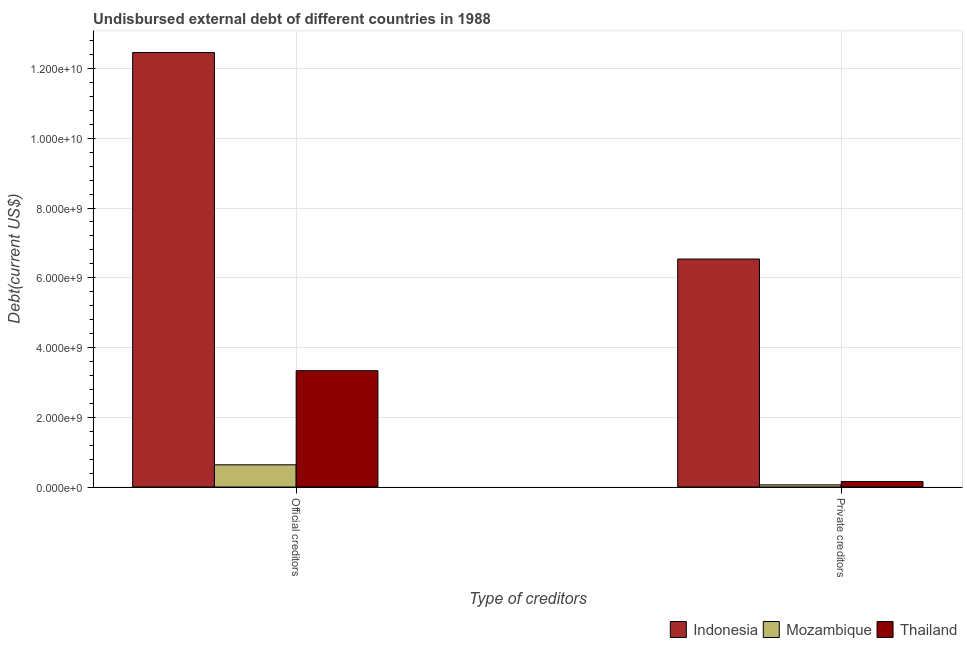How many different coloured bars are there?
Your response must be concise. 3. How many groups of bars are there?
Provide a short and direct response. 2. Are the number of bars per tick equal to the number of legend labels?
Offer a terse response. Yes. How many bars are there on the 1st tick from the left?
Provide a succinct answer. 3. How many bars are there on the 1st tick from the right?
Your response must be concise. 3. What is the label of the 1st group of bars from the left?
Give a very brief answer. Official creditors. What is the undisbursed external debt of private creditors in Mozambique?
Make the answer very short. 6.15e+07. Across all countries, what is the maximum undisbursed external debt of official creditors?
Your response must be concise. 1.25e+1. Across all countries, what is the minimum undisbursed external debt of official creditors?
Your response must be concise. 6.37e+08. In which country was the undisbursed external debt of official creditors maximum?
Provide a succinct answer. Indonesia. In which country was the undisbursed external debt of official creditors minimum?
Provide a succinct answer. Mozambique. What is the total undisbursed external debt of private creditors in the graph?
Make the answer very short. 6.76e+09. What is the difference between the undisbursed external debt of official creditors in Thailand and that in Indonesia?
Your response must be concise. -9.12e+09. What is the difference between the undisbursed external debt of private creditors in Thailand and the undisbursed external debt of official creditors in Indonesia?
Give a very brief answer. -1.23e+1. What is the average undisbursed external debt of private creditors per country?
Offer a very short reply. 2.25e+09. What is the difference between the undisbursed external debt of private creditors and undisbursed external debt of official creditors in Indonesia?
Ensure brevity in your answer.  -5.92e+09. What is the ratio of the undisbursed external debt of private creditors in Mozambique to that in Thailand?
Offer a terse response. 0.39. In how many countries, is the undisbursed external debt of official creditors greater than the average undisbursed external debt of official creditors taken over all countries?
Provide a short and direct response. 1. What does the 3rd bar from the left in Private creditors represents?
Give a very brief answer. Thailand. How many bars are there?
Make the answer very short. 6. Are all the bars in the graph horizontal?
Your answer should be compact. No. What is the difference between two consecutive major ticks on the Y-axis?
Ensure brevity in your answer.  2.00e+09. Does the graph contain any zero values?
Keep it short and to the point. No. How are the legend labels stacked?
Your answer should be very brief. Horizontal. What is the title of the graph?
Make the answer very short. Undisbursed external debt of different countries in 1988. What is the label or title of the X-axis?
Provide a short and direct response. Type of creditors. What is the label or title of the Y-axis?
Keep it short and to the point. Debt(current US$). What is the Debt(current US$) in Indonesia in Official creditors?
Your answer should be compact. 1.25e+1. What is the Debt(current US$) in Mozambique in Official creditors?
Provide a succinct answer. 6.37e+08. What is the Debt(current US$) of Thailand in Official creditors?
Give a very brief answer. 3.34e+09. What is the Debt(current US$) in Indonesia in Private creditors?
Provide a short and direct response. 6.54e+09. What is the Debt(current US$) in Mozambique in Private creditors?
Provide a succinct answer. 6.15e+07. What is the Debt(current US$) in Thailand in Private creditors?
Offer a terse response. 1.56e+08. Across all Type of creditors, what is the maximum Debt(current US$) in Indonesia?
Give a very brief answer. 1.25e+1. Across all Type of creditors, what is the maximum Debt(current US$) of Mozambique?
Provide a succinct answer. 6.37e+08. Across all Type of creditors, what is the maximum Debt(current US$) of Thailand?
Your response must be concise. 3.34e+09. Across all Type of creditors, what is the minimum Debt(current US$) of Indonesia?
Your answer should be compact. 6.54e+09. Across all Type of creditors, what is the minimum Debt(current US$) of Mozambique?
Offer a terse response. 6.15e+07. Across all Type of creditors, what is the minimum Debt(current US$) of Thailand?
Give a very brief answer. 1.56e+08. What is the total Debt(current US$) of Indonesia in the graph?
Make the answer very short. 1.90e+1. What is the total Debt(current US$) of Mozambique in the graph?
Provide a succinct answer. 6.98e+08. What is the total Debt(current US$) of Thailand in the graph?
Your answer should be very brief. 3.49e+09. What is the difference between the Debt(current US$) of Indonesia in Official creditors and that in Private creditors?
Provide a short and direct response. 5.92e+09. What is the difference between the Debt(current US$) in Mozambique in Official creditors and that in Private creditors?
Offer a very short reply. 5.75e+08. What is the difference between the Debt(current US$) in Thailand in Official creditors and that in Private creditors?
Offer a terse response. 3.18e+09. What is the difference between the Debt(current US$) of Indonesia in Official creditors and the Debt(current US$) of Mozambique in Private creditors?
Keep it short and to the point. 1.24e+1. What is the difference between the Debt(current US$) of Indonesia in Official creditors and the Debt(current US$) of Thailand in Private creditors?
Ensure brevity in your answer.  1.23e+1. What is the difference between the Debt(current US$) of Mozambique in Official creditors and the Debt(current US$) of Thailand in Private creditors?
Keep it short and to the point. 4.80e+08. What is the average Debt(current US$) in Indonesia per Type of creditors?
Offer a very short reply. 9.50e+09. What is the average Debt(current US$) in Mozambique per Type of creditors?
Your response must be concise. 3.49e+08. What is the average Debt(current US$) of Thailand per Type of creditors?
Your answer should be compact. 1.75e+09. What is the difference between the Debt(current US$) in Indonesia and Debt(current US$) in Mozambique in Official creditors?
Your response must be concise. 1.18e+1. What is the difference between the Debt(current US$) in Indonesia and Debt(current US$) in Thailand in Official creditors?
Make the answer very short. 9.12e+09. What is the difference between the Debt(current US$) in Mozambique and Debt(current US$) in Thailand in Official creditors?
Offer a very short reply. -2.70e+09. What is the difference between the Debt(current US$) in Indonesia and Debt(current US$) in Mozambique in Private creditors?
Your response must be concise. 6.48e+09. What is the difference between the Debt(current US$) of Indonesia and Debt(current US$) of Thailand in Private creditors?
Keep it short and to the point. 6.38e+09. What is the difference between the Debt(current US$) in Mozambique and Debt(current US$) in Thailand in Private creditors?
Your answer should be very brief. -9.49e+07. What is the ratio of the Debt(current US$) of Indonesia in Official creditors to that in Private creditors?
Ensure brevity in your answer.  1.91. What is the ratio of the Debt(current US$) of Mozambique in Official creditors to that in Private creditors?
Offer a terse response. 10.35. What is the ratio of the Debt(current US$) in Thailand in Official creditors to that in Private creditors?
Your answer should be very brief. 21.33. What is the difference between the highest and the second highest Debt(current US$) in Indonesia?
Ensure brevity in your answer.  5.92e+09. What is the difference between the highest and the second highest Debt(current US$) of Mozambique?
Ensure brevity in your answer.  5.75e+08. What is the difference between the highest and the second highest Debt(current US$) in Thailand?
Offer a very short reply. 3.18e+09. What is the difference between the highest and the lowest Debt(current US$) of Indonesia?
Your answer should be very brief. 5.92e+09. What is the difference between the highest and the lowest Debt(current US$) in Mozambique?
Give a very brief answer. 5.75e+08. What is the difference between the highest and the lowest Debt(current US$) of Thailand?
Keep it short and to the point. 3.18e+09. 